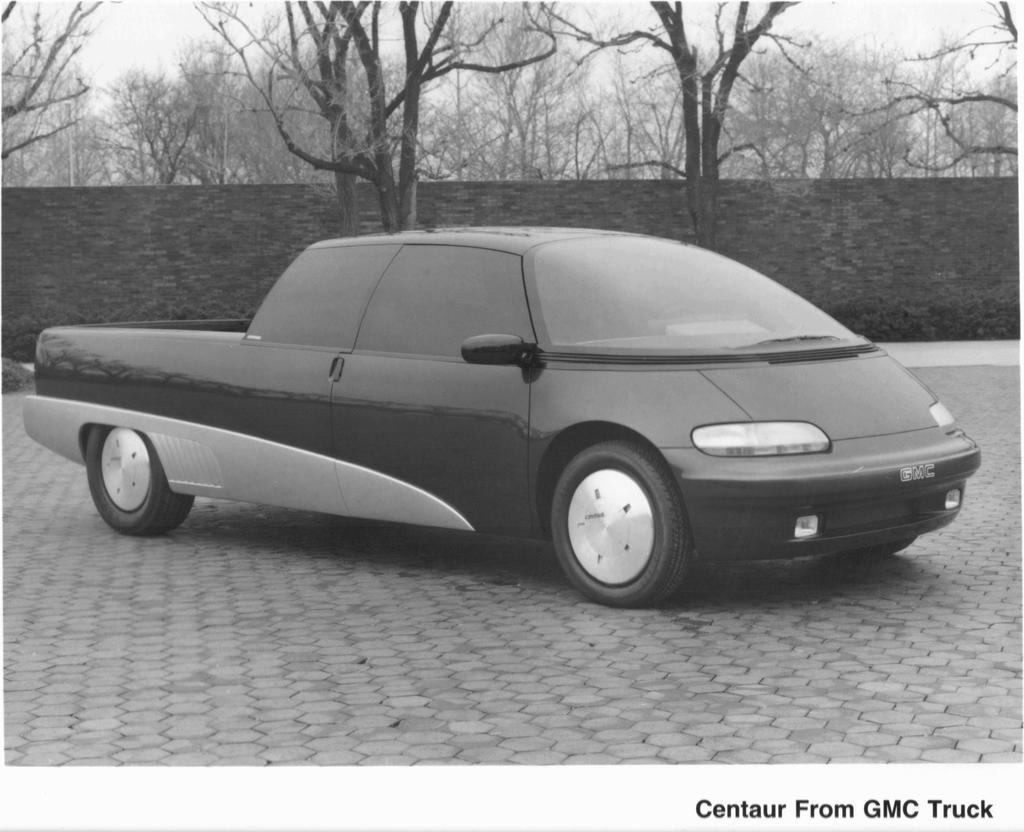Could you give a brief overview of what you see in this image? This is a black and white pic. We can see a vehicle on the road. In the background we can see bare trees, wall and sky. 